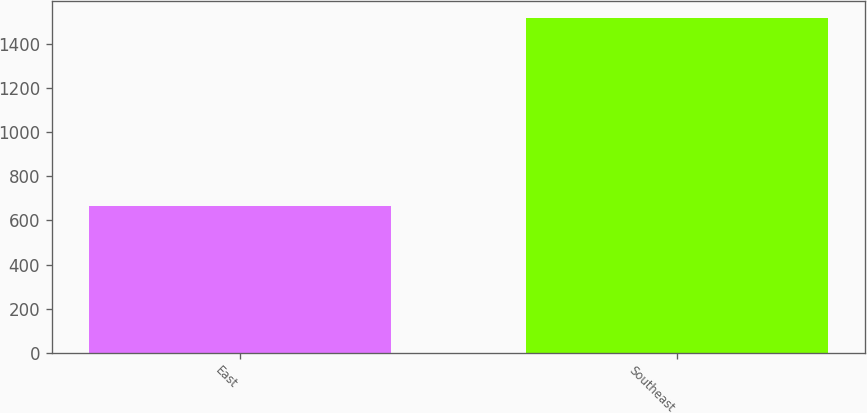<chart> <loc_0><loc_0><loc_500><loc_500><bar_chart><fcel>East<fcel>Southeast<nl><fcel>667.8<fcel>1520.4<nl></chart> 